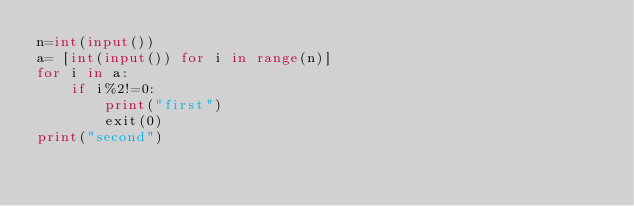<code> <loc_0><loc_0><loc_500><loc_500><_Python_>n=int(input())
a= [int(input()) for i in range(n)]
for i in a:
    if i%2!=0:
        print("first")
        exit(0)
print("second")</code> 